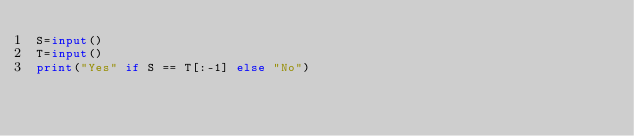<code> <loc_0><loc_0><loc_500><loc_500><_Python_>S=input()
T=input()
print("Yes" if S == T[:-1] else "No")</code> 